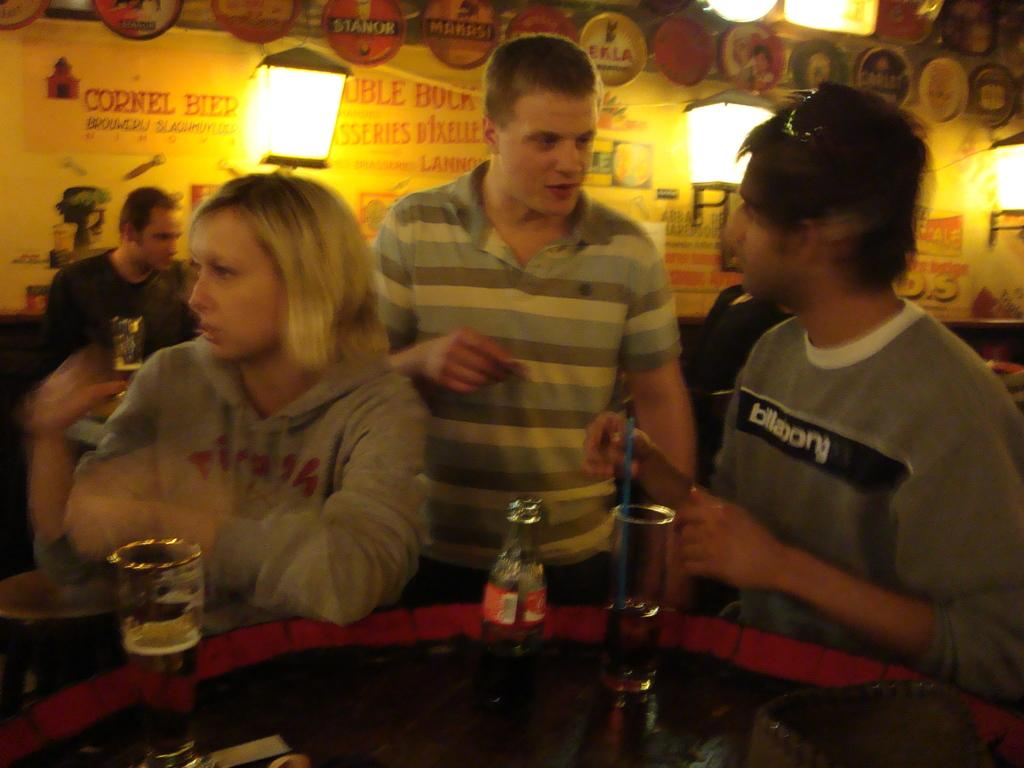What are the people near in the image? The people are standing near a table. What objects can be seen on the table? There are glasses and bottles on the table. What can be seen in the background of the image? There are lights and a wall in the background. Is there a band playing under the moon in the image? There is no band or moon present in the image. What are the people learning in the image? The image does not show any learning activities; it features people standing near a table with glasses and bottles. 